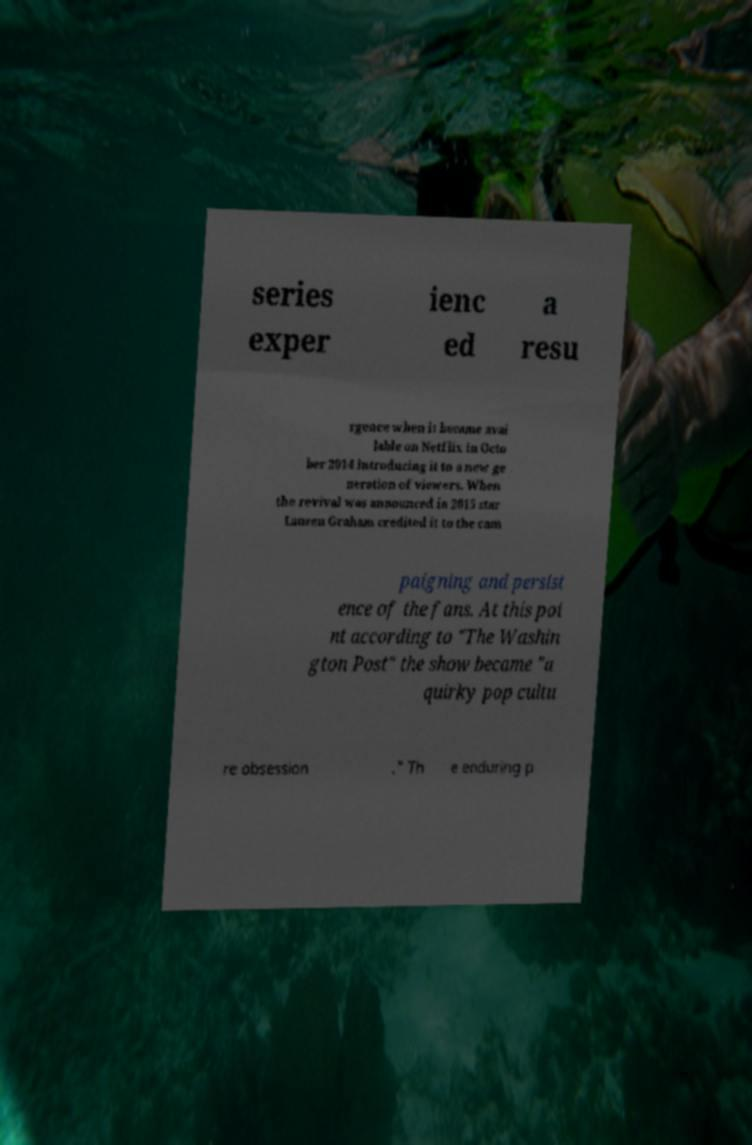Can you read and provide the text displayed in the image?This photo seems to have some interesting text. Can you extract and type it out for me? series exper ienc ed a resu rgence when it became avai lable on Netflix in Octo ber 2014 introducing it to a new ge neration of viewers. When the revival was announced in 2015 star Lauren Graham credited it to the cam paigning and persist ence of the fans. At this poi nt according to "The Washin gton Post" the show became "a quirky pop cultu re obsession ." Th e enduring p 